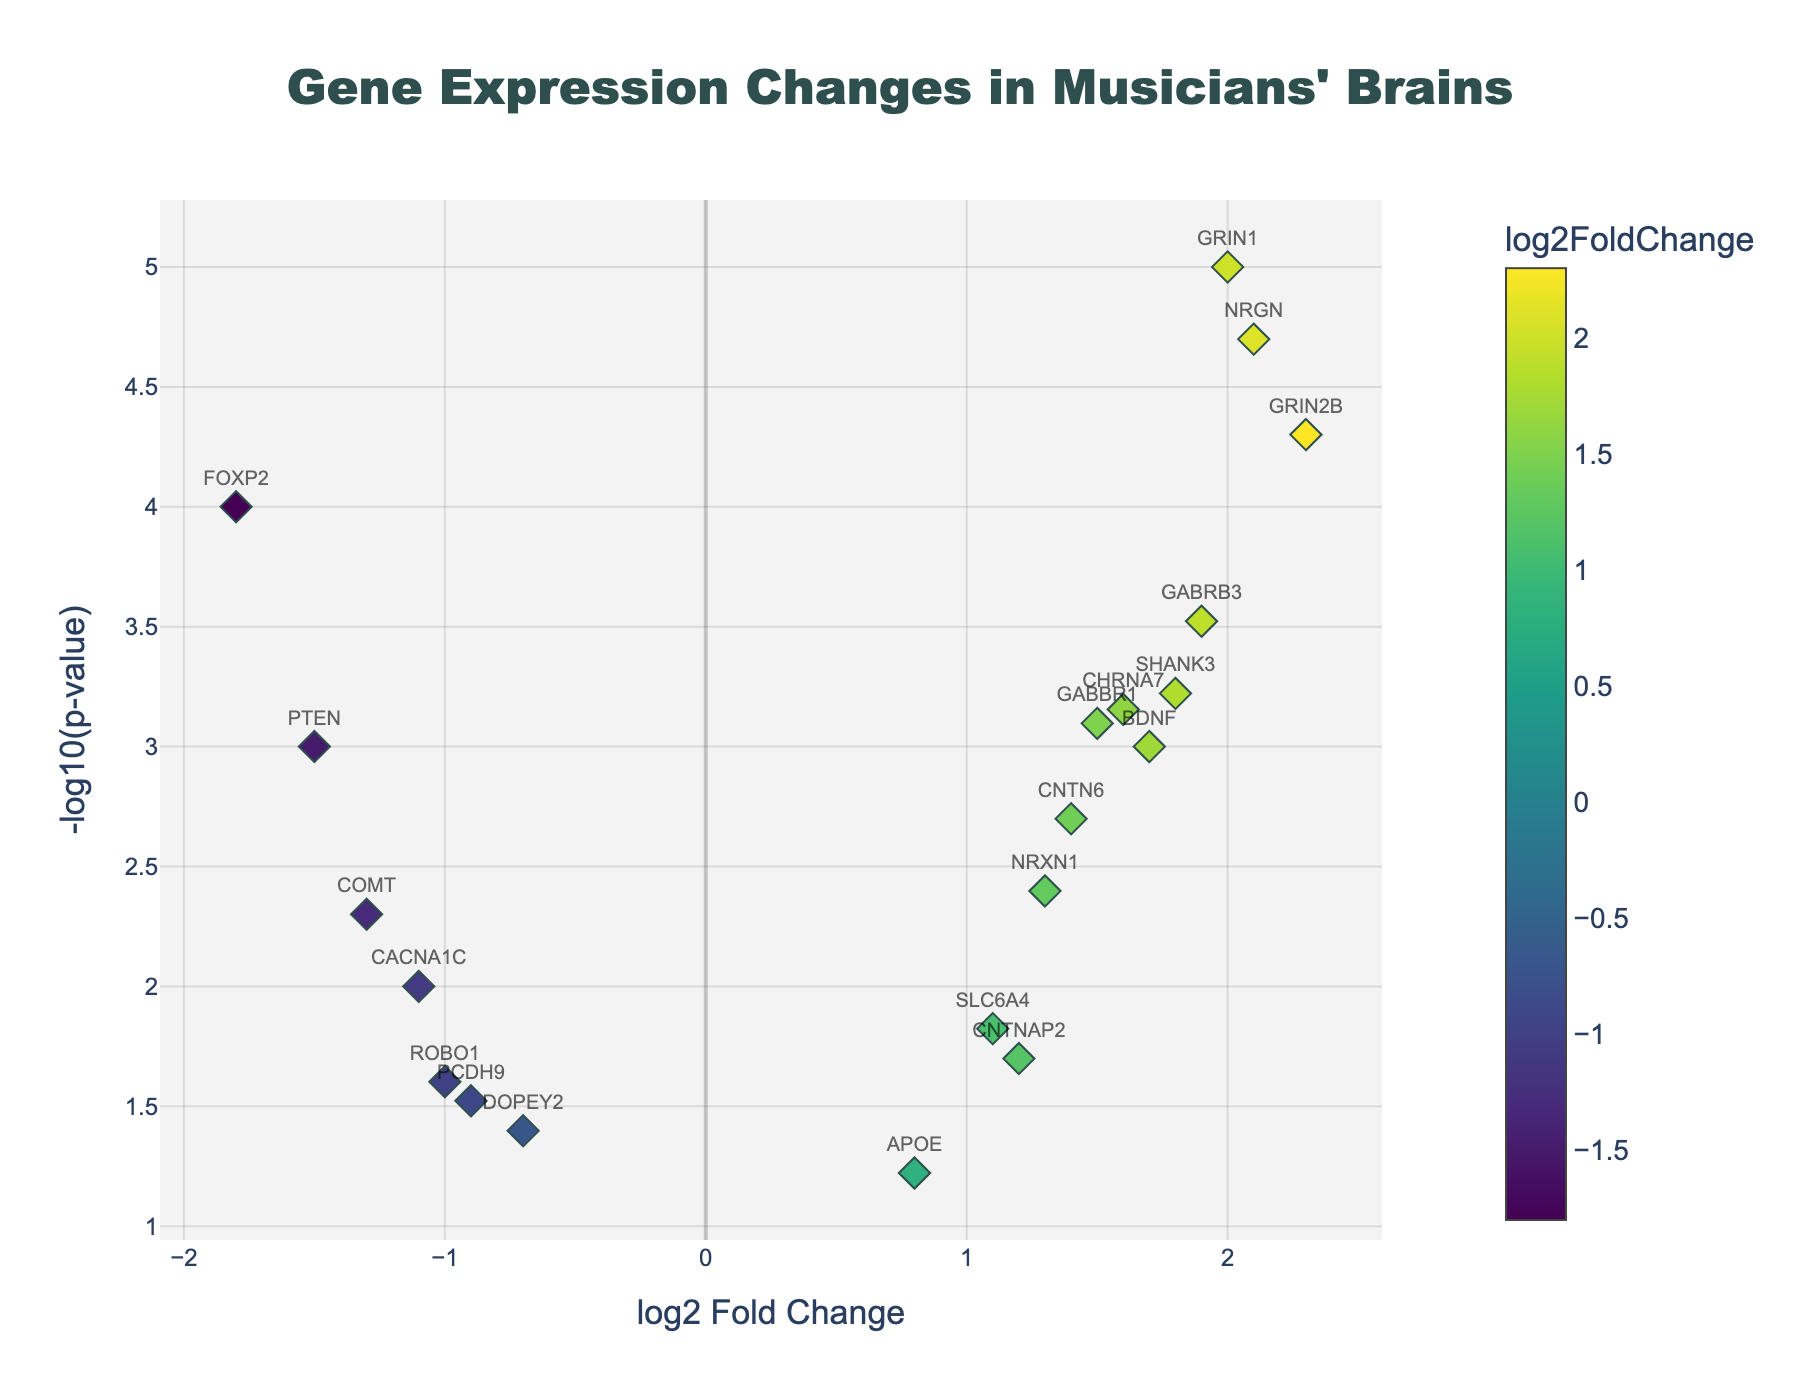What does the title of the plot indicate? The title at the top of the plot reads "Gene Expression Changes in Musicians' Brains," indicating that the plot shows changes in gene expression between musicians and non-musicians.
Answer: Gene Expression Changes in Musicians' Brains How many genes showed significant expression changes (p-value < 0.05)? To determine this, we need to count the genes with a -log10(p-value) greater than -log10(0.05), which is approximately 1.3. From the plot, identify markers above this threshold.
Answer: 15 Which gene has the highest log2 fold change? We identify the point on the x-axis with the highest positive log2 fold change value.
Answer: GRIN2B Which gene has the lowest log2 fold change? We identify the point on the x-axis with the lowest (most negative) log2 fold change value.
Answer: FOXP2 What does the color of the markers represent? The legend indicates that the color of each marker represents its log2 fold change based on a Viridis colorscale.
Answer: log2 Fold Change Which genes related to auditory processing have significant expression changes? By examining the plot and focusing on genes known to be associated with auditory processing (like FOXP2, GRIN1, and NRXN1), we identify those with p-values < 0.05.
Answer: FOXP2, GRIN1, NRXN1 Between the genes GRIN1 and NRGN, which has a more significant p-value? Look at the -log10(p-value) for both genes. The gene with a higher -log10(p-value) is more significant.
Answer: NRGN Which genes related to motor skills show increased expression in musicians? Identify genes related to motor skills with positive log2 fold changes. BDNF and SHANK3 are examples related to motor skills.
Answer: BDNF, SHANK3 How does the gene APOE compare to other genes in terms of log2 fold change and p-value? APOE has a log2 fold change of 0.8 and a p-value around 0.06, placing it below the significance threshold and having a modest log2 fold change compared to others.
Answer: Moderate log2 fold change, not significant 